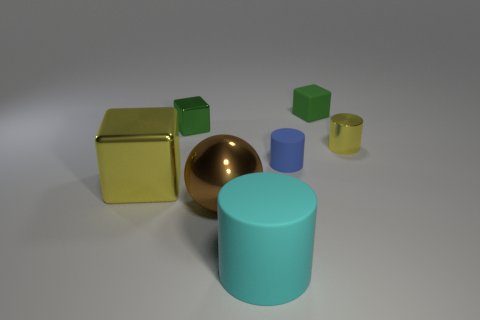Subtract all metal blocks. How many blocks are left? 1 Subtract 0 gray spheres. How many objects are left? 7 Subtract all spheres. How many objects are left? 6 Subtract 2 cylinders. How many cylinders are left? 1 Subtract all blue cylinders. Subtract all purple blocks. How many cylinders are left? 2 Subtract all gray blocks. How many purple balls are left? 0 Subtract all brown metallic spheres. Subtract all tiny green matte cubes. How many objects are left? 5 Add 4 rubber things. How many rubber things are left? 7 Add 1 yellow cubes. How many yellow cubes exist? 2 Add 3 blue rubber cylinders. How many objects exist? 10 